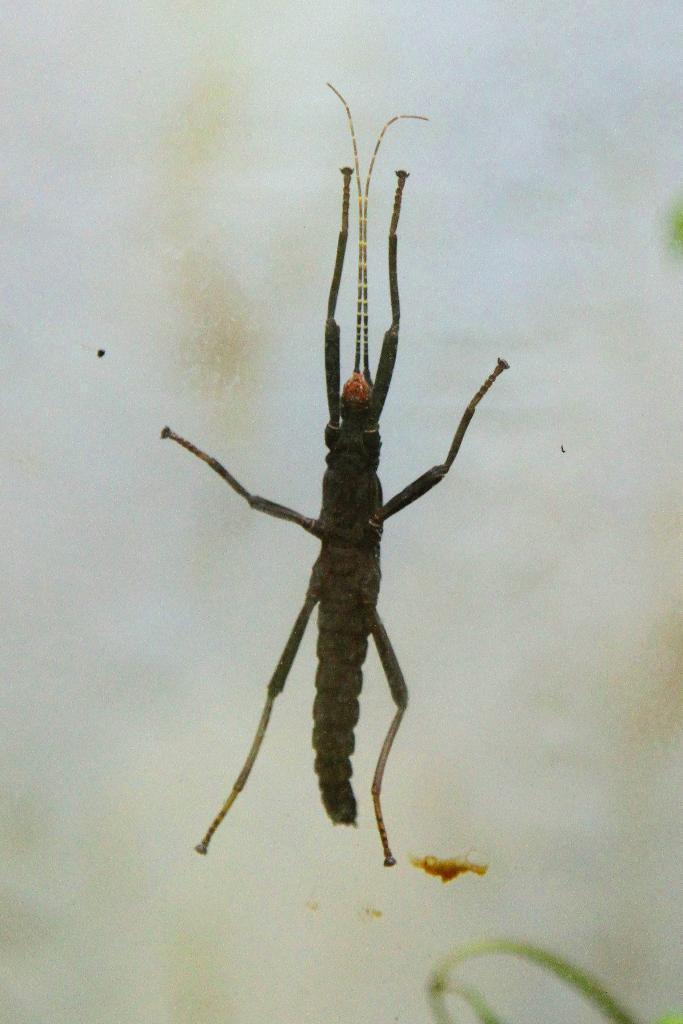Can you describe this image briefly? In this picture I can see an insect which is of black color and it is on the white color surface. 